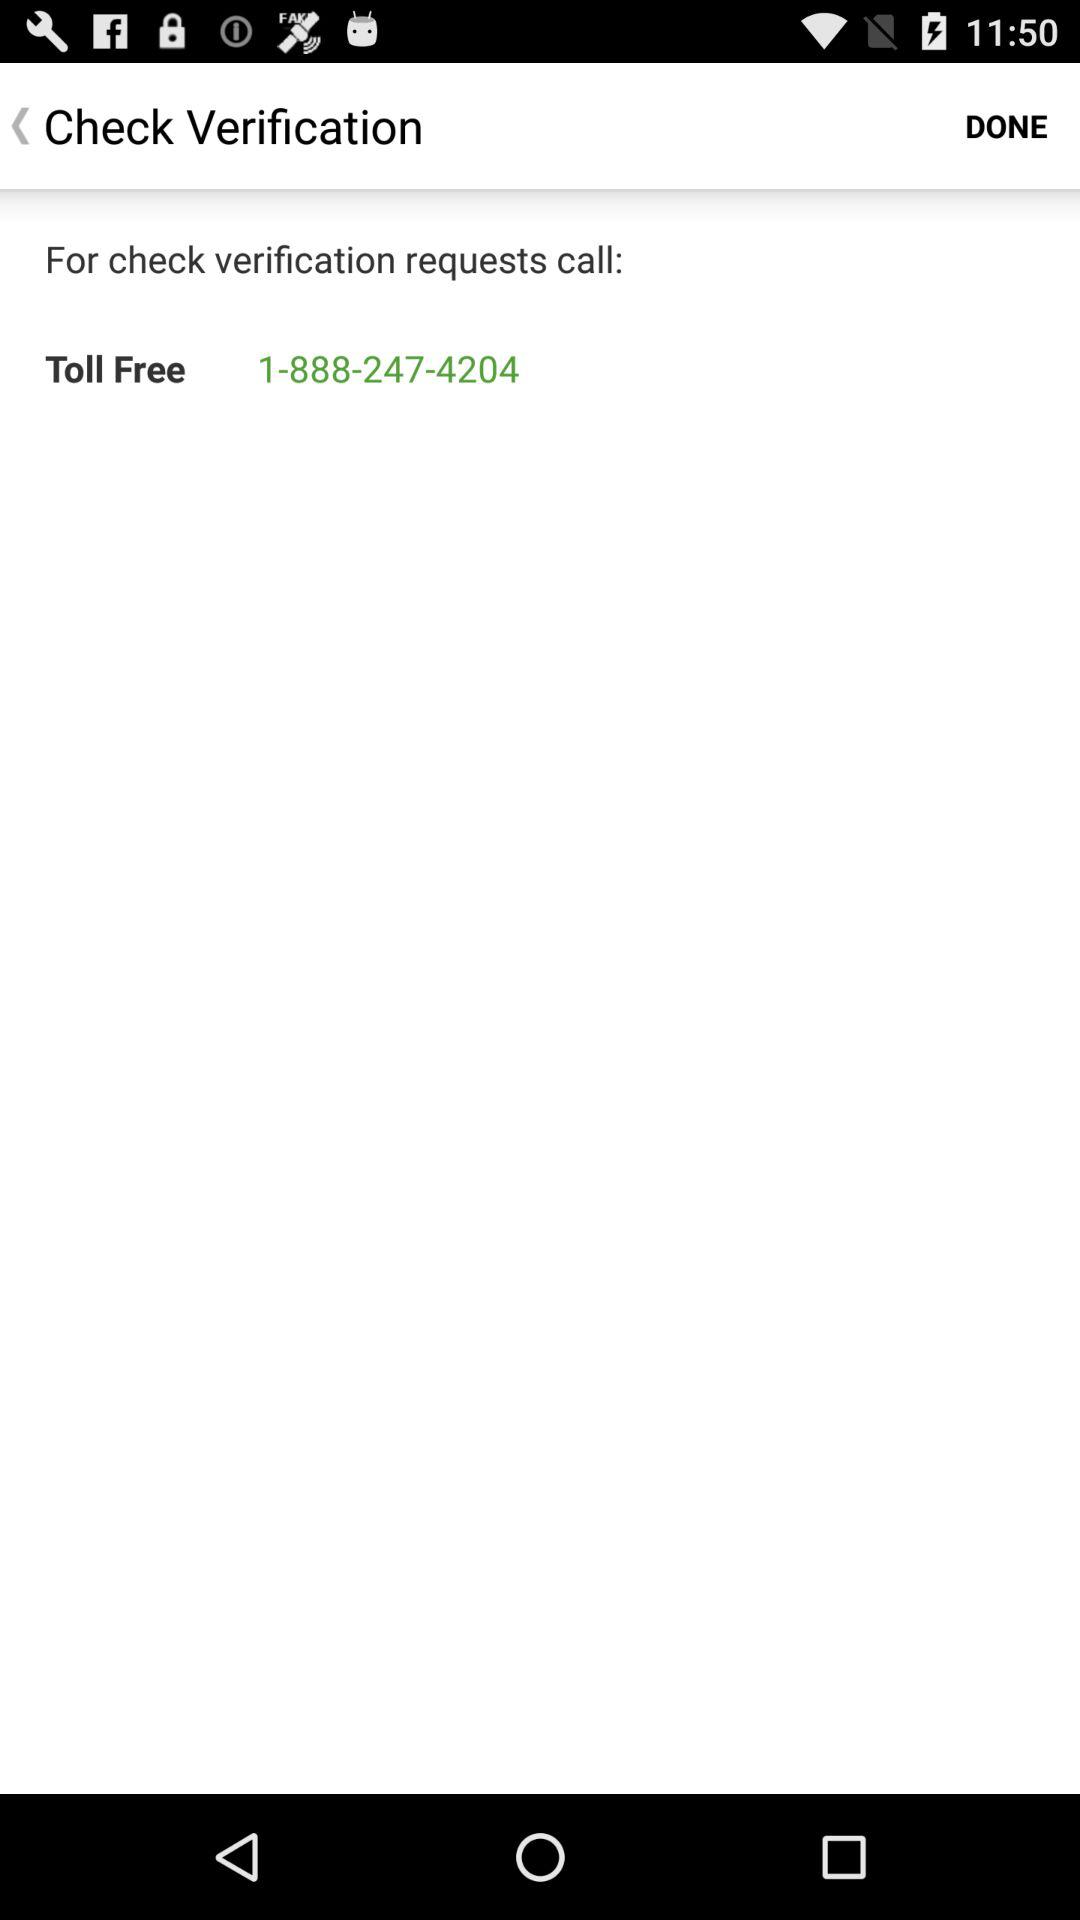What is the given toll-free number? The given toll-free number is 1-888-247-4204. 